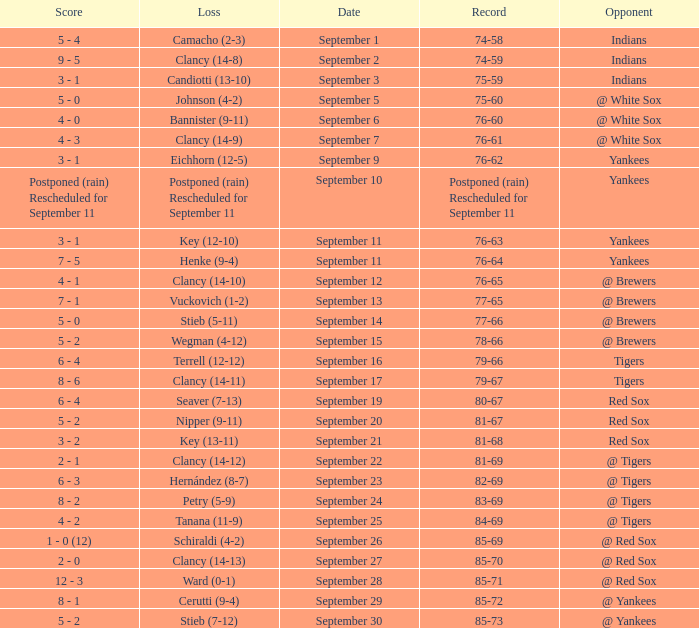What was the date of the game when their record was 84-69? September 25. 